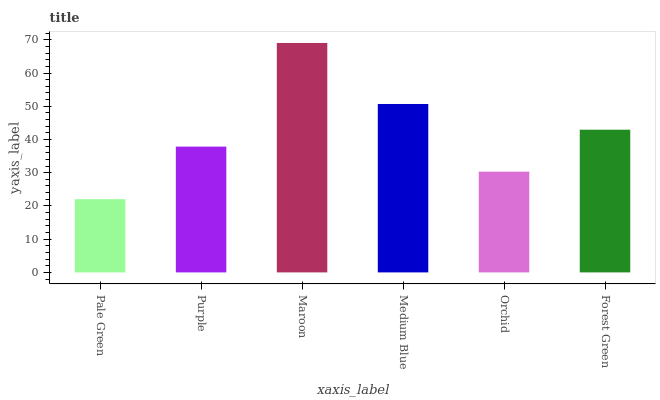Is Purple the minimum?
Answer yes or no. No. Is Purple the maximum?
Answer yes or no. No. Is Purple greater than Pale Green?
Answer yes or no. Yes. Is Pale Green less than Purple?
Answer yes or no. Yes. Is Pale Green greater than Purple?
Answer yes or no. No. Is Purple less than Pale Green?
Answer yes or no. No. Is Forest Green the high median?
Answer yes or no. Yes. Is Purple the low median?
Answer yes or no. Yes. Is Maroon the high median?
Answer yes or no. No. Is Maroon the low median?
Answer yes or no. No. 